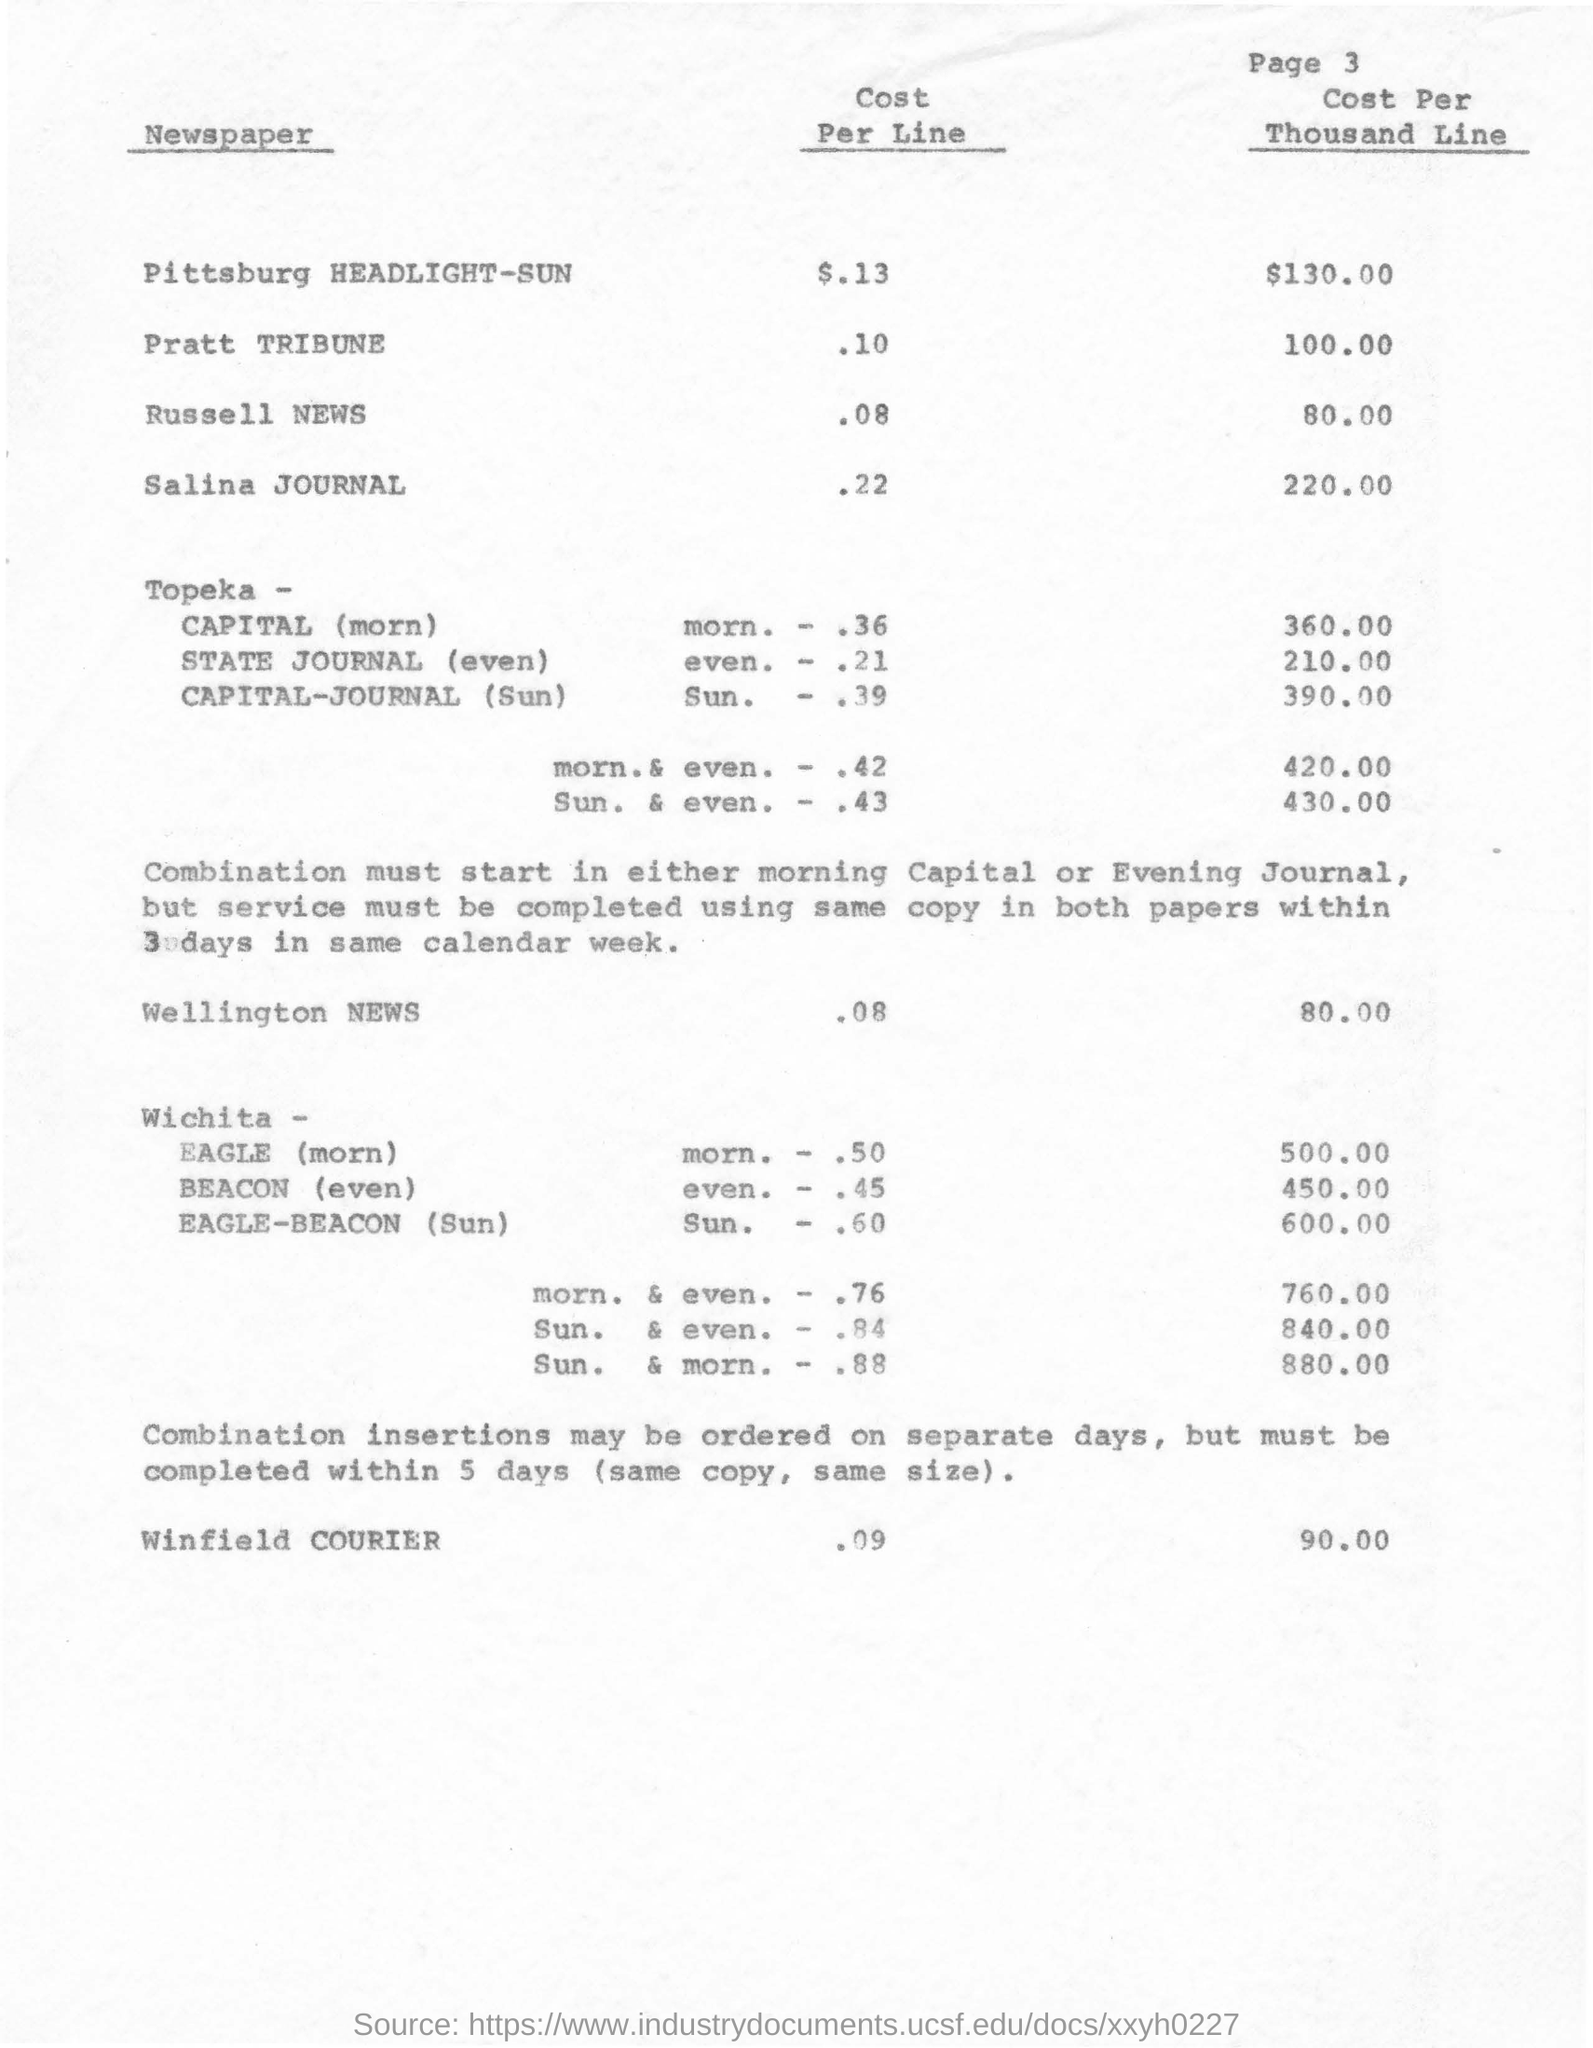What is the page no mentioned in this document?
Offer a terse response. 3. What is the Cost Per Line for Pratt Tribune Newspaper?
Give a very brief answer. .10. What is the Cost Per Thousand Line for Pittsburg HEADLIGHT-SUN Newspaper?
Provide a short and direct response. $130.00. What is the Cost Per Line for Winfield COURIER?
Offer a terse response. .09. 